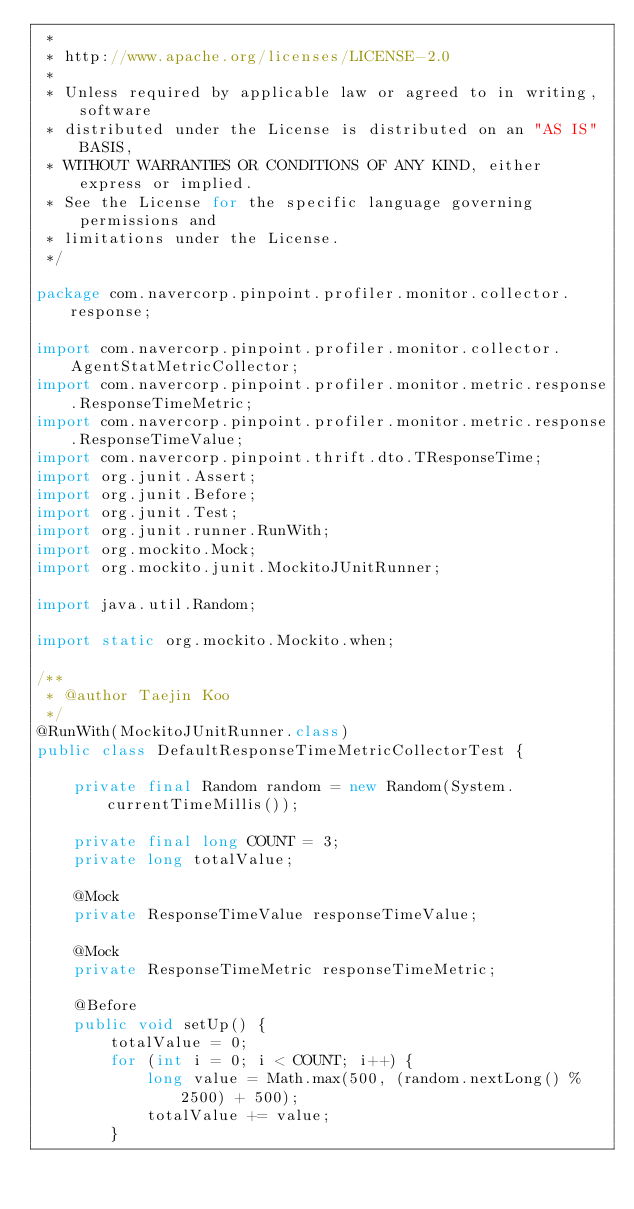Convert code to text. <code><loc_0><loc_0><loc_500><loc_500><_Java_> *
 * http://www.apache.org/licenses/LICENSE-2.0
 *
 * Unless required by applicable law or agreed to in writing, software
 * distributed under the License is distributed on an "AS IS" BASIS,
 * WITHOUT WARRANTIES OR CONDITIONS OF ANY KIND, either express or implied.
 * See the License for the specific language governing permissions and
 * limitations under the License.
 */

package com.navercorp.pinpoint.profiler.monitor.collector.response;

import com.navercorp.pinpoint.profiler.monitor.collector.AgentStatMetricCollector;
import com.navercorp.pinpoint.profiler.monitor.metric.response.ResponseTimeMetric;
import com.navercorp.pinpoint.profiler.monitor.metric.response.ResponseTimeValue;
import com.navercorp.pinpoint.thrift.dto.TResponseTime;
import org.junit.Assert;
import org.junit.Before;
import org.junit.Test;
import org.junit.runner.RunWith;
import org.mockito.Mock;
import org.mockito.junit.MockitoJUnitRunner;

import java.util.Random;

import static org.mockito.Mockito.when;

/**
 * @author Taejin Koo
 */
@RunWith(MockitoJUnitRunner.class)
public class DefaultResponseTimeMetricCollectorTest {

    private final Random random = new Random(System.currentTimeMillis());

    private final long COUNT = 3;
    private long totalValue;

    @Mock
    private ResponseTimeValue responseTimeValue;

    @Mock
    private ResponseTimeMetric responseTimeMetric;

    @Before
    public void setUp() {
        totalValue = 0;
        for (int i = 0; i < COUNT; i++) {
            long value = Math.max(500, (random.nextLong() % 2500) + 500);
            totalValue += value;
        }
</code> 